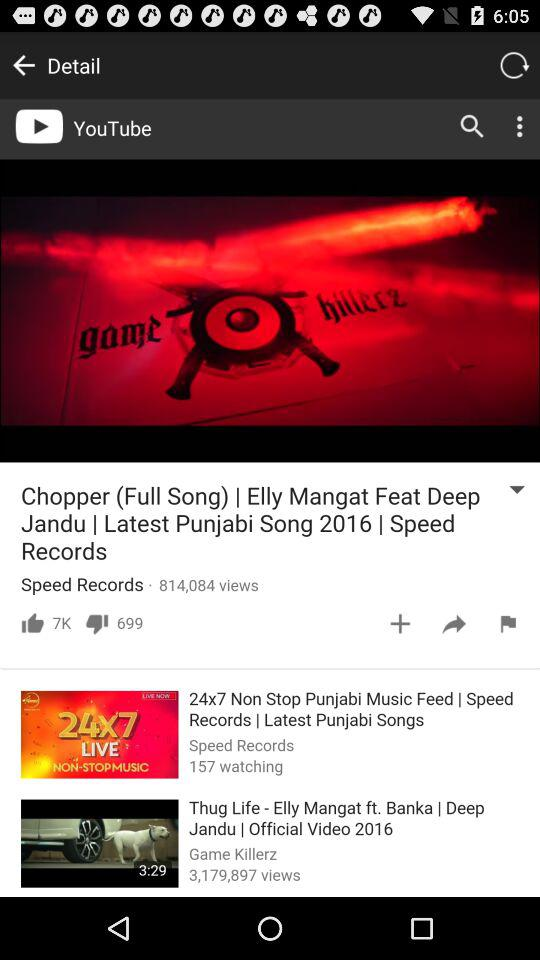What is the length of the video "Thug Life"? The length of the video "Thug Life" is 3 minutes and 29 seconds. 